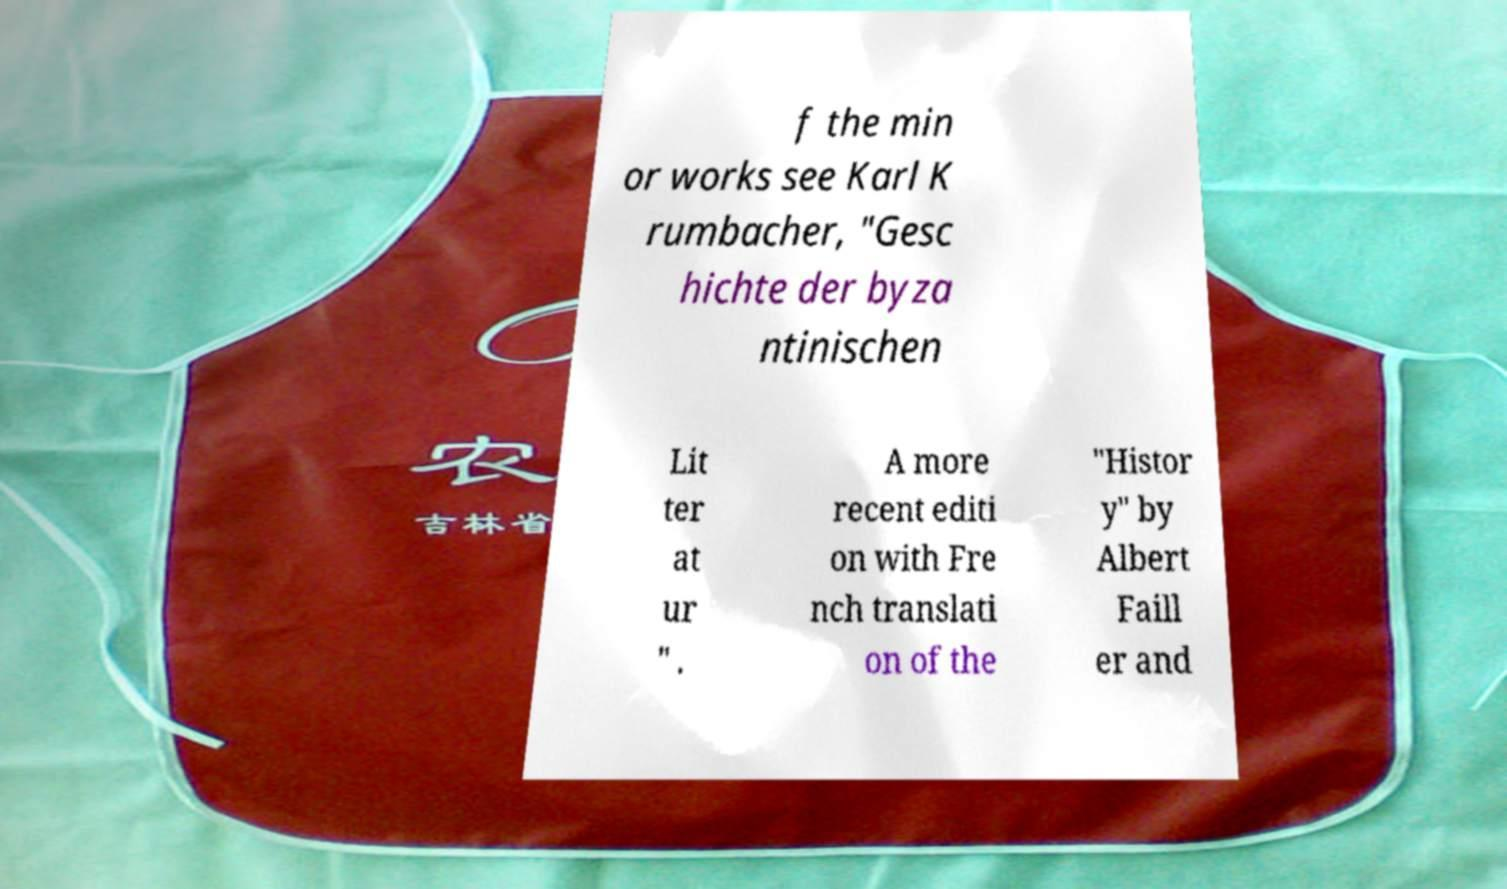Could you assist in decoding the text presented in this image and type it out clearly? f the min or works see Karl K rumbacher, "Gesc hichte der byza ntinischen Lit ter at ur " . A more recent editi on with Fre nch translati on of the "Histor y" by Albert Faill er and 